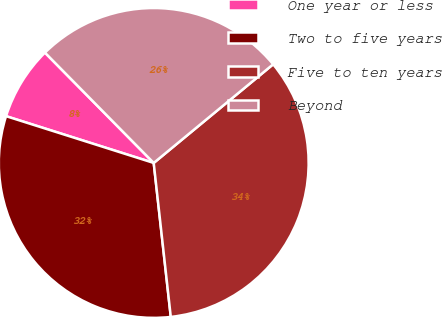Convert chart. <chart><loc_0><loc_0><loc_500><loc_500><pie_chart><fcel>One year or less<fcel>Two to five years<fcel>Five to ten years<fcel>Beyond<nl><fcel>7.73%<fcel>31.64%<fcel>34.23%<fcel>26.4%<nl></chart> 